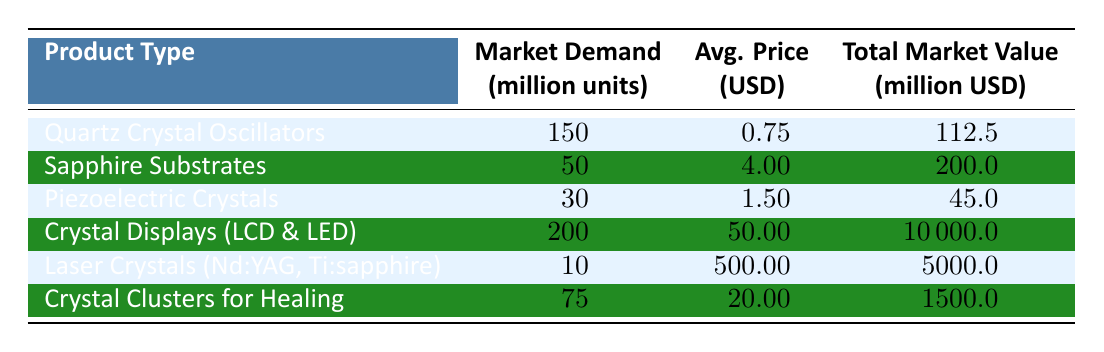What is the market demand for Crystal Displays (LCD & LED)? According to the table, the market demand for Crystal Displays (LCD & LED) is listed as 200 million units.
Answer: 200 million units What is the total market value of Sapphire Substrates? The table shows that the total market value of Sapphire Substrates is 200 million USD.
Answer: 200 million USD Which product type has the highest average price per unit? By comparing the average prices per unit in the table, Laser Crystals (Nd:YAG, Ti:sapphire) has the highest average price at 500.00 USD per unit.
Answer: Laser Crystals (Nd:YAG, Ti:sapphire) How many million units are required for Piezoelectric Crystals and Crystal Clusters for Healing combined? The combined market demand is calculated by summing the values for Piezoelectric Crystals (30 million units) and Crystal Clusters for Healing (75 million units), which is 30 + 75 = 105 million units.
Answer: 105 million units Is the total market value of Crystal Displays greater than the combined total market values of Piezoelectric Crystals and Sapphire Substrates? The total market value of Crystal Displays is 10000 million USD, while the combined total for Piezoelectric Crystals (45 million USD) and Sapphire Substrates (200 million USD) is 245 million USD. Since 10000 million is significantly greater than 245 million, the statement is true.
Answer: Yes What percentage of the total market value does the market demand for Quartz Crystal Oscillators represent? To find the percentage, first, note that the total market value of all products is the sum of the individual total market values (10000 + 5000 + 200 + 45 + 1500 + 112.5 = 16757.5 million USD). The market value for Quartz Crystal Oscillators is 112.5 million USD. The percentage is (112.5 / 16757.5) * 100, which equals approximately 0.67%.
Answer: Approximately 0.67% Are there more million units of Laser Crystals sold than Quartz Crystal Oscillators? The market demand for Laser Crystals is 10 million units, while Quartz Crystal Oscillators have a demand of 150 million units. Since 10 is less than 150, the statement is false.
Answer: No What is the average market price per unit of all products combined? The average price is calculated by first finding the total revenue from all products (10000 + 5000 + 200 + 45 + 1500 + 112.5 = 16757.5 million USD) and then dividing by the total market demand (200 + 10 + 30 + 50 + 75 + 150 = 515 million units). The average price per unit is 16757.5 million USD / 515 million units, which is approximately 32.5 USD.
Answer: Approximately 32.5 USD 